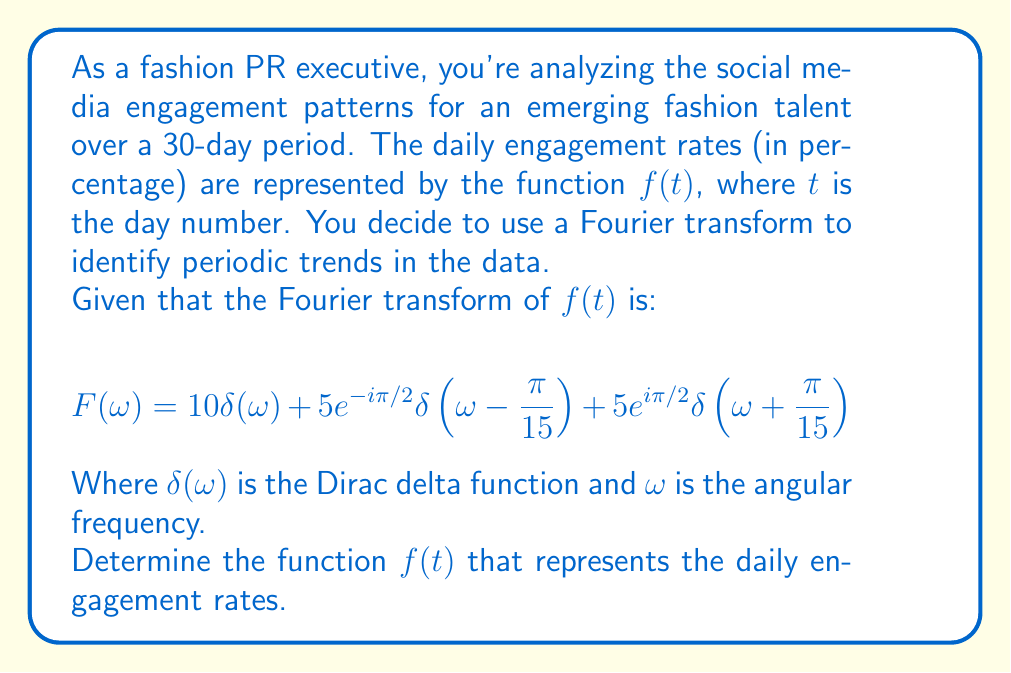Teach me how to tackle this problem. Let's approach this step-by-step:

1) The Fourier transform pair for a cosine function is:
   $$\cos(\omega_0 t) \leftrightarrow \pi[\delta(\omega - \omega_0) + \delta(\omega + \omega_0)]$$

2) The Fourier transform pair for a sine function is:
   $$\sin(\omega_0 t) \leftrightarrow -i\pi[\delta(\omega - \omega_0) - \delta(\omega + \omega_0)]$$

3) In our given Fourier transform:
   $$F(\omega) = 10\delta(\omega) + 5e^{-i\pi/2}\delta(\omega - \frac{\pi}{15}) + 5e^{i\pi/2}\delta(\omega + \frac{\pi}{15})$$

4) The first term, $10\delta(\omega)$, represents a constant in the time domain. Its inverse Fourier transform is 10.

5) For the second and third terms, we can rewrite them as:
   $$5[-i\delta(\omega - \frac{\pi}{15}) + i\delta(\omega + \frac{\pi}{15})]$$

6) Comparing this with the Fourier transform of sine, we can see that it represents:
   $$5\sin(\frac{\pi}{15}t)$$

7) Therefore, the inverse Fourier transform of $F(\omega)$ is:
   $$f(t) = 10 + 5\sin(\frac{\pi}{15}t)$$

This function represents the daily engagement rates over the 30-day period.
Answer: $f(t) = 10 + 5\sin(\frac{\pi}{15}t)$ 